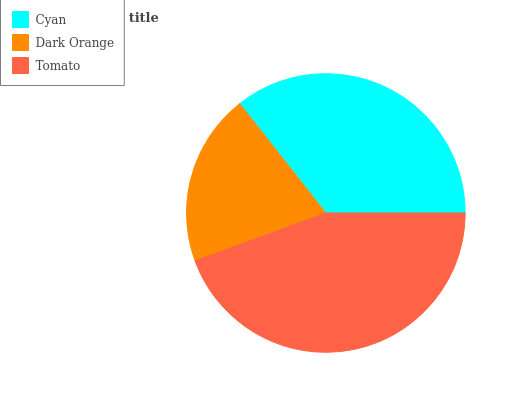Is Dark Orange the minimum?
Answer yes or no. Yes. Is Tomato the maximum?
Answer yes or no. Yes. Is Tomato the minimum?
Answer yes or no. No. Is Dark Orange the maximum?
Answer yes or no. No. Is Tomato greater than Dark Orange?
Answer yes or no. Yes. Is Dark Orange less than Tomato?
Answer yes or no. Yes. Is Dark Orange greater than Tomato?
Answer yes or no. No. Is Tomato less than Dark Orange?
Answer yes or no. No. Is Cyan the high median?
Answer yes or no. Yes. Is Cyan the low median?
Answer yes or no. Yes. Is Tomato the high median?
Answer yes or no. No. Is Dark Orange the low median?
Answer yes or no. No. 